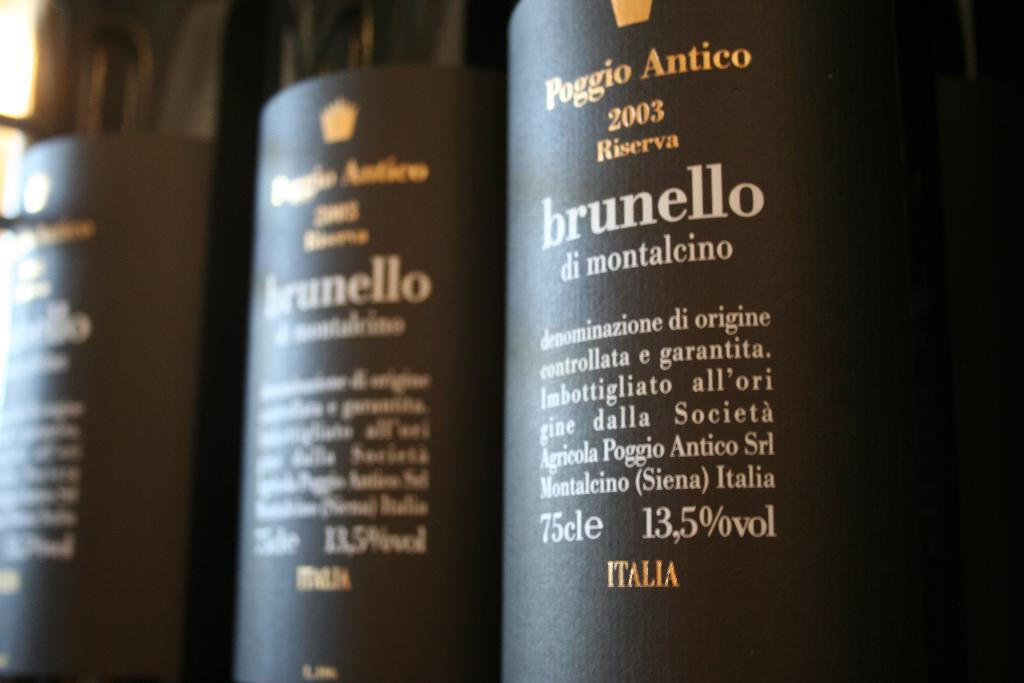<image>
Present a compact description of the photo's key features. A row of hair care products by brunello di montalcino. 